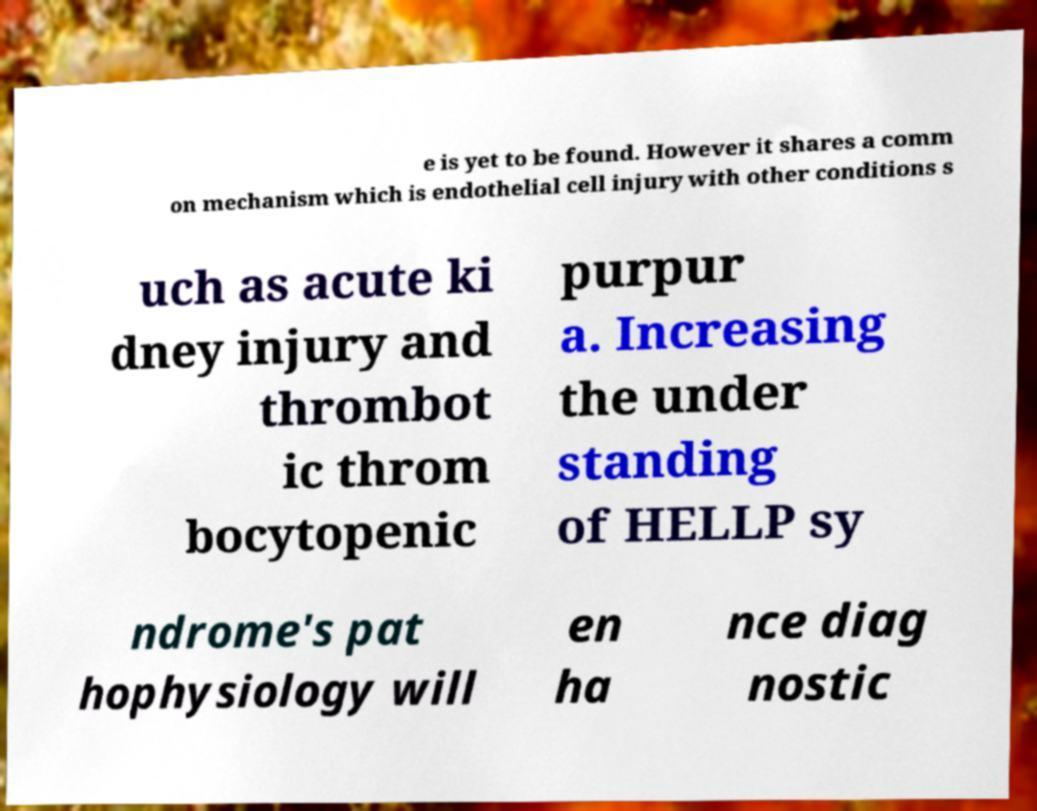Could you extract and type out the text from this image? e is yet to be found. However it shares a comm on mechanism which is endothelial cell injury with other conditions s uch as acute ki dney injury and thrombot ic throm bocytopenic purpur a. Increasing the under standing of HELLP sy ndrome's pat hophysiology will en ha nce diag nostic 